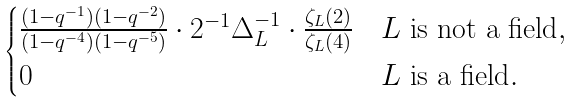Convert formula to latex. <formula><loc_0><loc_0><loc_500><loc_500>\begin{cases} \frac { ( 1 - q ^ { - 1 } ) ( 1 - q ^ { - 2 } ) } { ( 1 - q ^ { - 4 } ) ( 1 - q ^ { - 5 } ) } \cdot 2 ^ { - 1 } \Delta _ { L } ^ { - 1 } \cdot \frac { \zeta _ { L } ( 2 ) } { \zeta _ { L } ( 4 ) } & \text {$L$ is not a field} , \\ 0 & \text {$L$ is a field} . \\ \end{cases}</formula> 